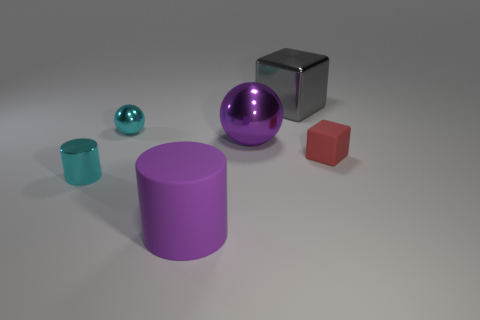Subtract 1 cubes. How many cubes are left? 1 Subtract 0 green cylinders. How many objects are left? 6 Subtract all cubes. How many objects are left? 4 Subtract all yellow balls. Subtract all cyan cylinders. How many balls are left? 2 Subtract all brown balls. How many green cubes are left? 0 Subtract all cyan metal things. Subtract all big green balls. How many objects are left? 4 Add 1 large metallic spheres. How many large metallic spheres are left? 2 Add 4 small red matte things. How many small red matte things exist? 5 Add 1 rubber spheres. How many objects exist? 7 Subtract all red blocks. How many blocks are left? 1 